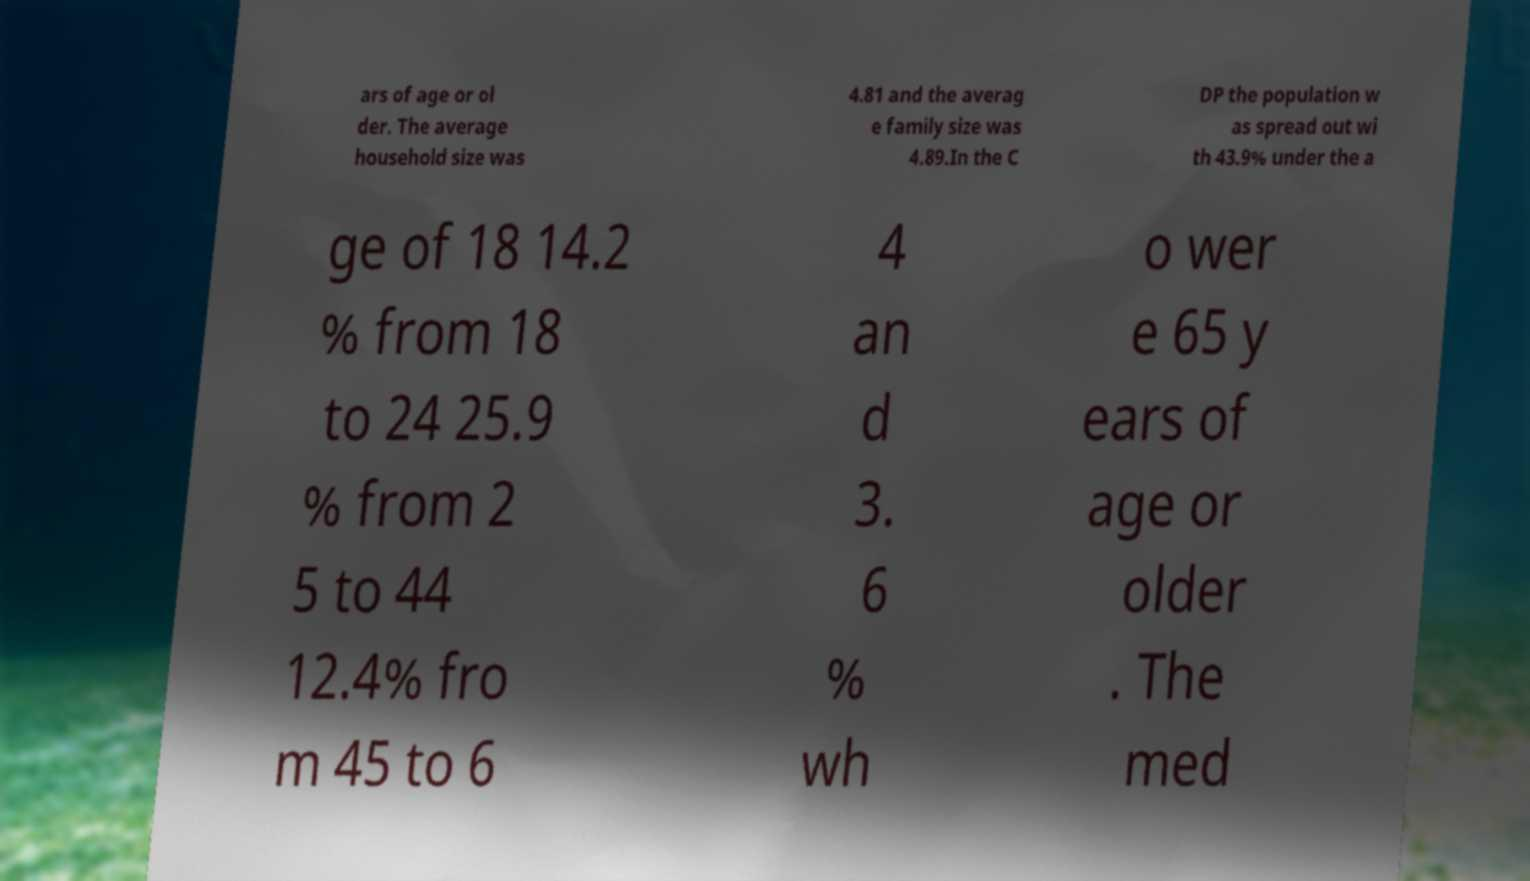For documentation purposes, I need the text within this image transcribed. Could you provide that? ars of age or ol der. The average household size was 4.81 and the averag e family size was 4.89.In the C DP the population w as spread out wi th 43.9% under the a ge of 18 14.2 % from 18 to 24 25.9 % from 2 5 to 44 12.4% fro m 45 to 6 4 an d 3. 6 % wh o wer e 65 y ears of age or older . The med 